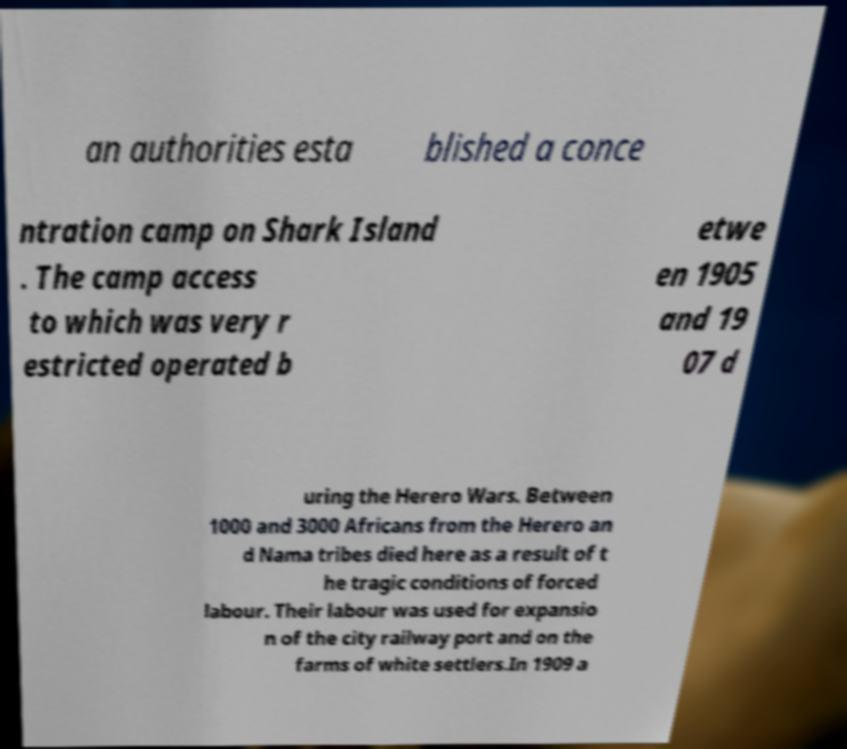What messages or text are displayed in this image? I need them in a readable, typed format. an authorities esta blished a conce ntration camp on Shark Island . The camp access to which was very r estricted operated b etwe en 1905 and 19 07 d uring the Herero Wars. Between 1000 and 3000 Africans from the Herero an d Nama tribes died here as a result of t he tragic conditions of forced labour. Their labour was used for expansio n of the city railway port and on the farms of white settlers.In 1909 a 